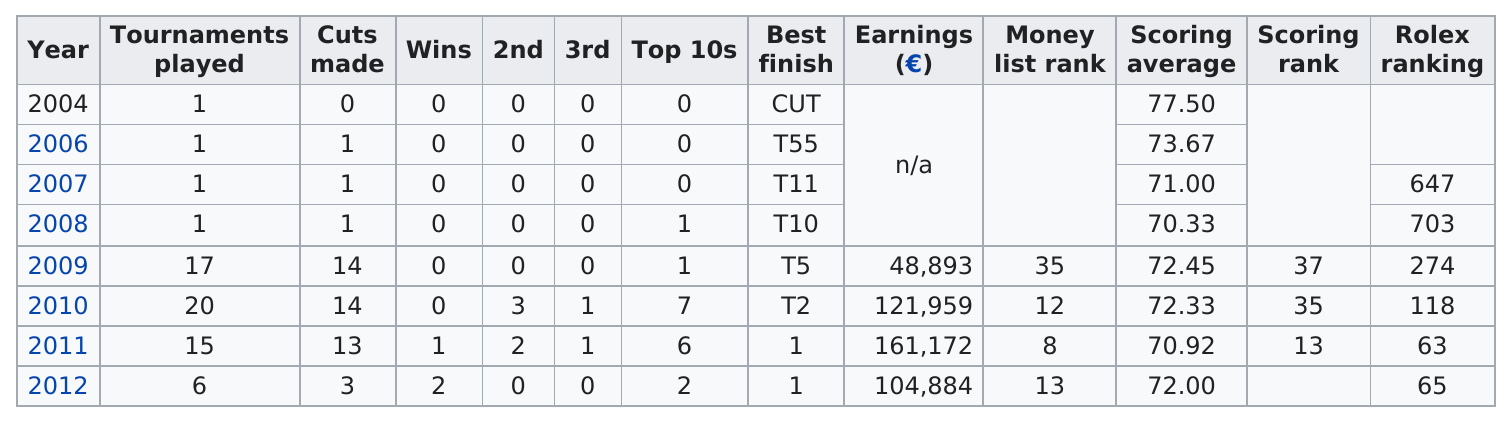Outline some significant characteristics in this image. The player with the lowest scoring average among those who played in 2008 is the least. In 2012, Christel Boeljon scored an average of 72.00 in her In the golfer's career, the year with the most 2nd place finishes was 2010. As an amateur, Christel Boeljon last played on the Ladies European Tour in the year 2008. Christel Boeljon has had a total of 17 top-10 finishes on the Ladies European Tour. 